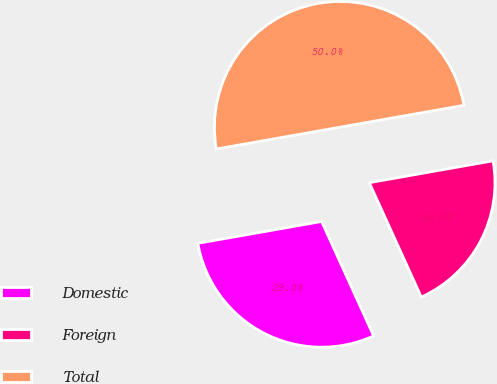Convert chart. <chart><loc_0><loc_0><loc_500><loc_500><pie_chart><fcel>Domestic<fcel>Foreign<fcel>Total<nl><fcel>29.01%<fcel>20.99%<fcel>50.0%<nl></chart> 